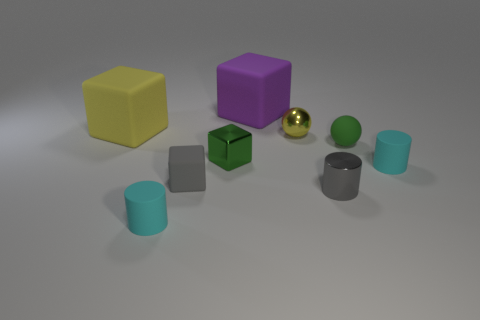Can you tell me the likely function of the small golden ball? The small golden ball resembles a simple decorative item, potentially serving as an ornamental piece given its reflective surface and attractive color that stands out from the other objects. 